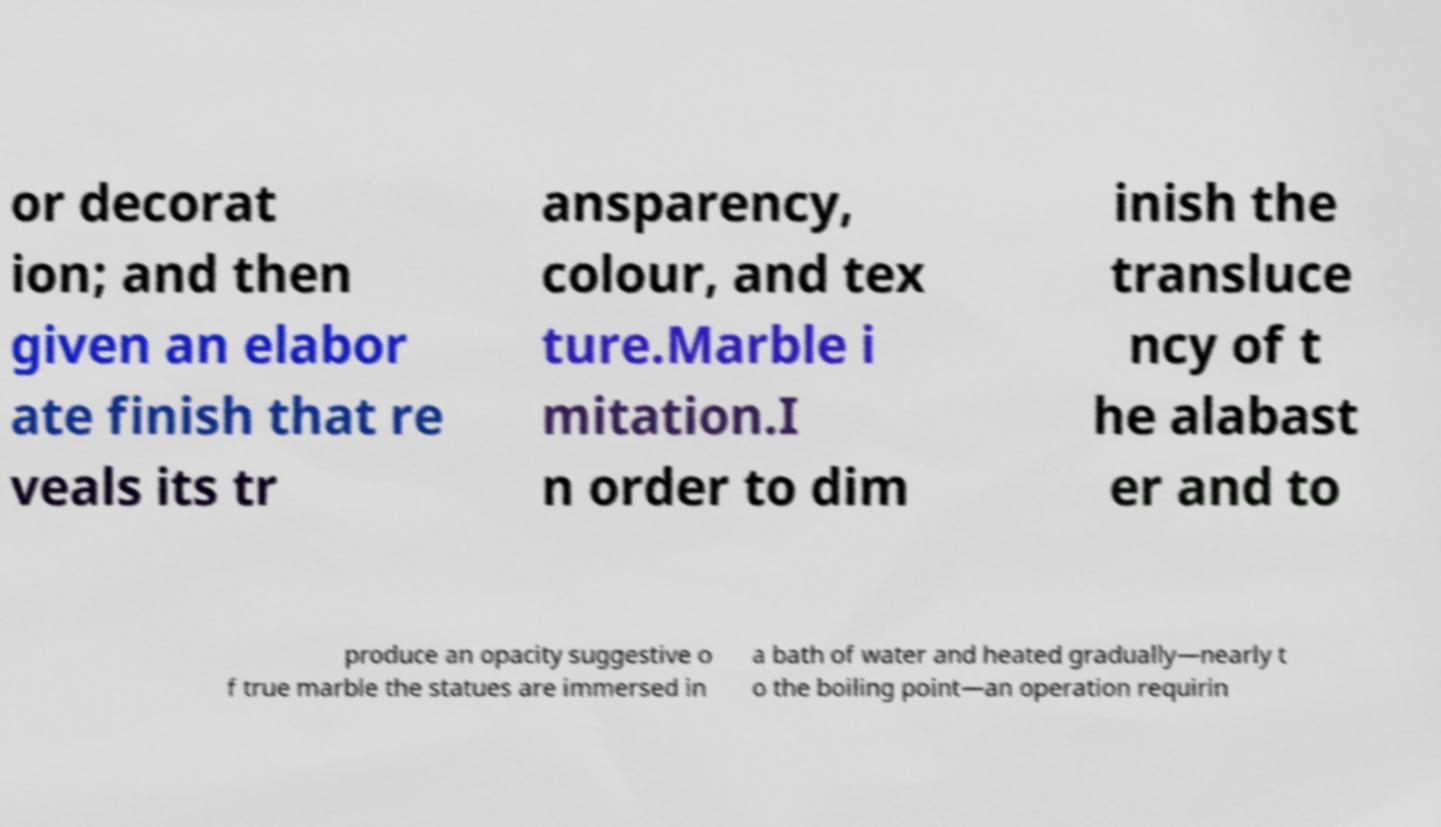There's text embedded in this image that I need extracted. Can you transcribe it verbatim? or decorat ion; and then given an elabor ate finish that re veals its tr ansparency, colour, and tex ture.Marble i mitation.I n order to dim inish the transluce ncy of t he alabast er and to produce an opacity suggestive o f true marble the statues are immersed in a bath of water and heated gradually—nearly t o the boiling point—an operation requirin 